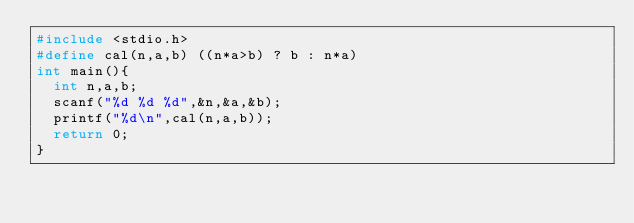Convert code to text. <code><loc_0><loc_0><loc_500><loc_500><_C_>#include <stdio.h>
#define cal(n,a,b) ((n*a>b) ? b : n*a)
int main(){
  int n,a,b;
  scanf("%d %d %d",&n,&a,&b);
  printf("%d\n",cal(n,a,b));
  return 0;
}
</code> 